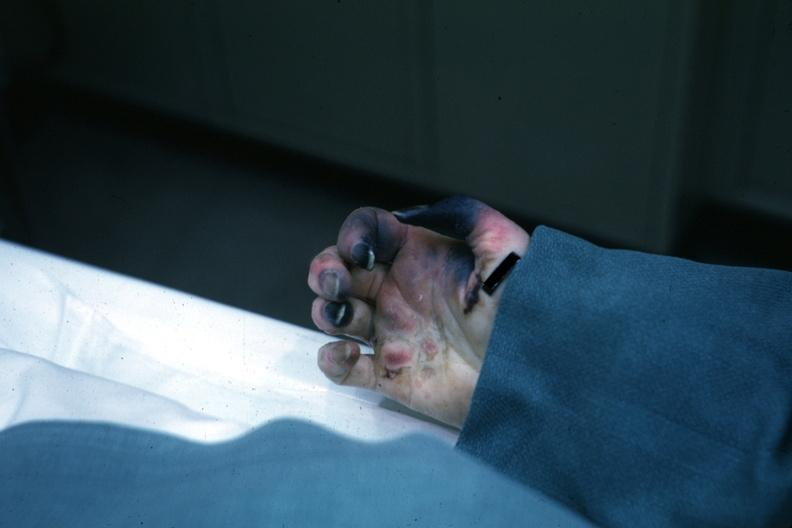does this image show obvious gangrenous necrosis child with congenital heart disease post op exact cause not know shock vs emboli?
Answer the question using a single word or phrase. Yes 